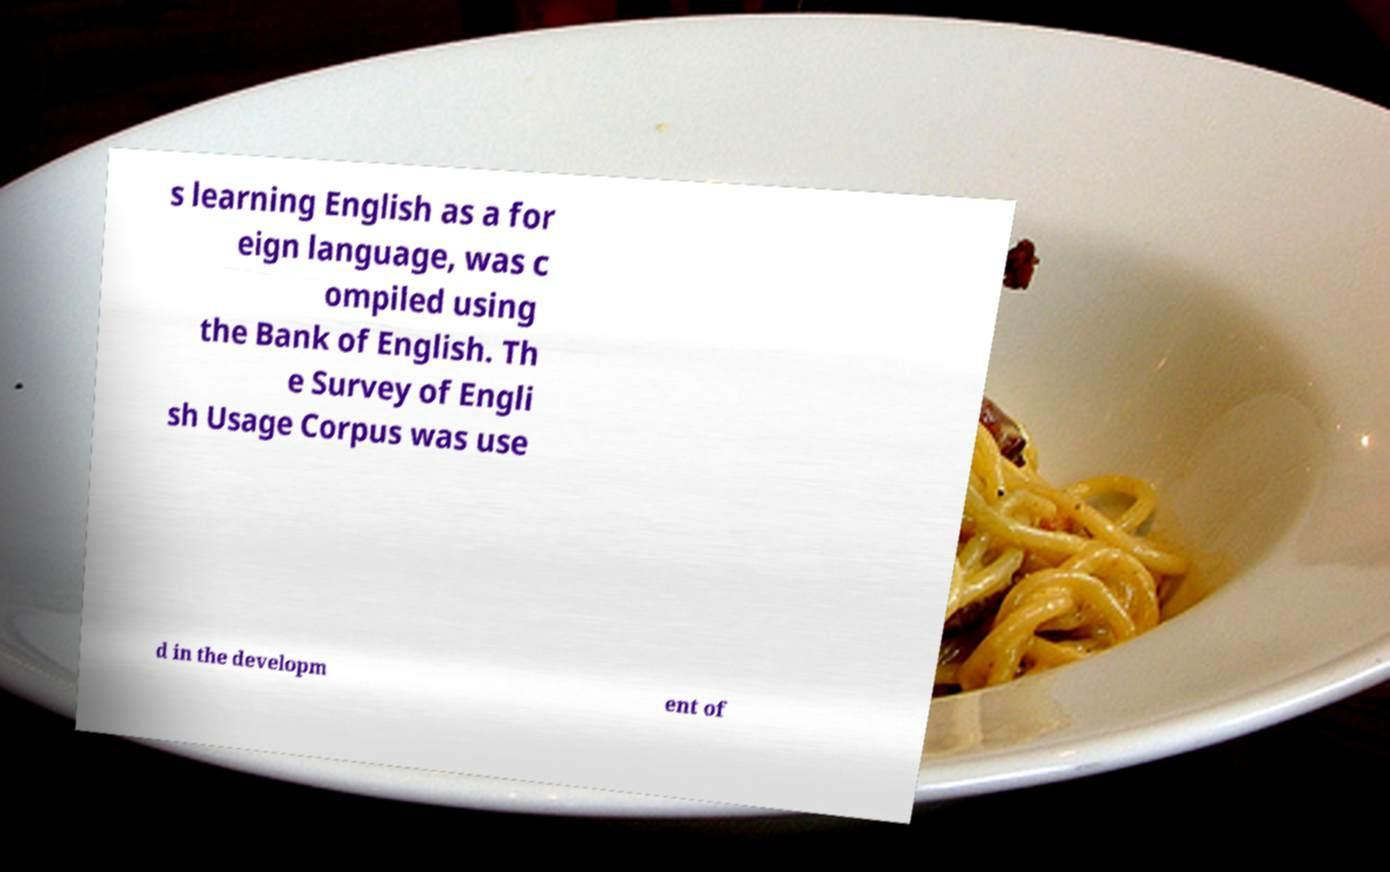Please read and relay the text visible in this image. What does it say? s learning English as a for eign language, was c ompiled using the Bank of English. Th e Survey of Engli sh Usage Corpus was use d in the developm ent of 